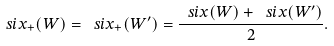Convert formula to latex. <formula><loc_0><loc_0><loc_500><loc_500>\ s i x _ { + } ( W ) = \ s i x _ { + } ( W ^ { \prime } ) = \frac { \ s i x ( W ) + \ s i x ( W ^ { \prime } ) } { 2 } .</formula> 